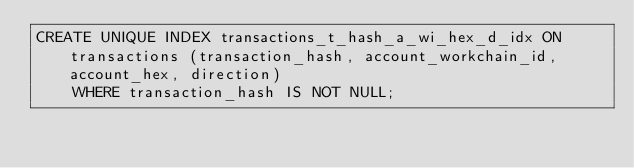Convert code to text. <code><loc_0><loc_0><loc_500><loc_500><_SQL_>CREATE UNIQUE INDEX transactions_t_hash_a_wi_hex_d_idx ON transactions (transaction_hash, account_workchain_id, account_hex, direction)
    WHERE transaction_hash IS NOT NULL;
</code> 